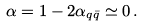Convert formula to latex. <formula><loc_0><loc_0><loc_500><loc_500>\alpha = 1 - 2 \alpha _ { q \bar { q } } \simeq 0 \, .</formula> 